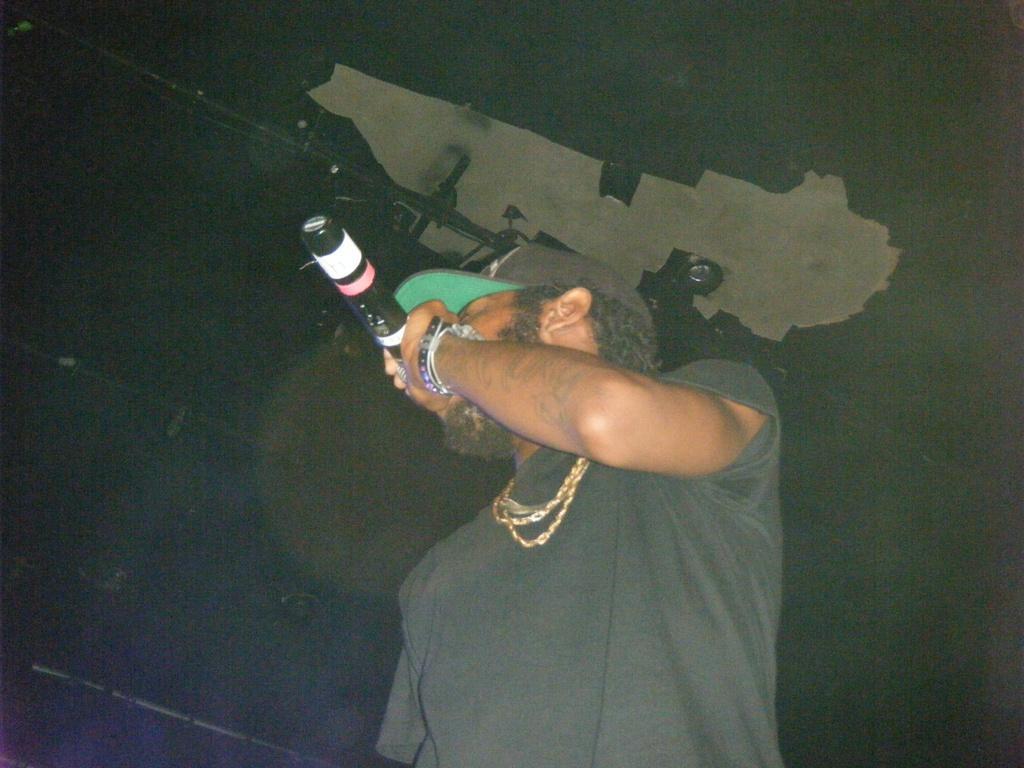In one or two sentences, can you explain what this image depicts? In this image we can see one person standing and holding a microphone. There are some objects attached to the ceiling and wall. 